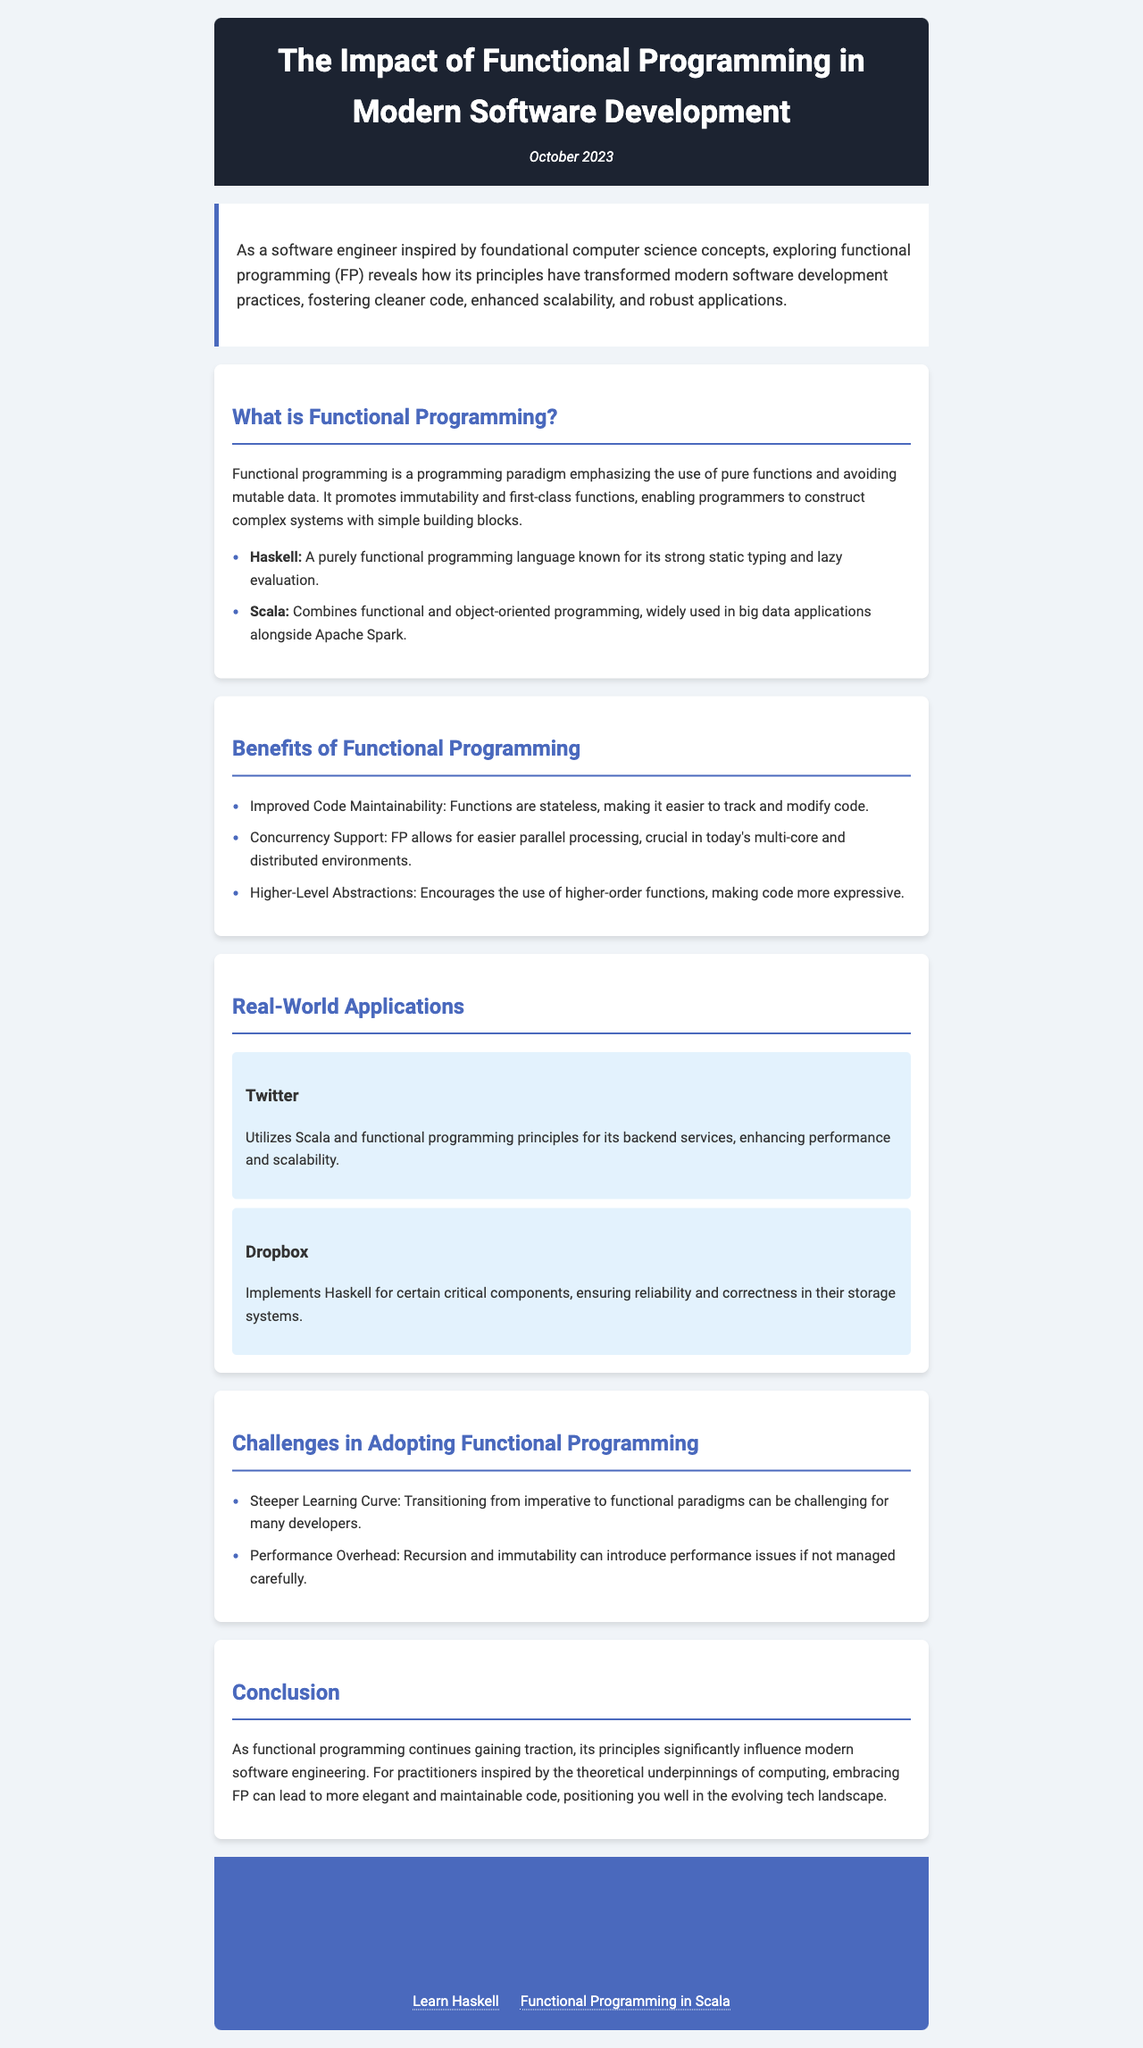What is the date of the newsletter? The date of the newsletter is mentioned in the header section.
Answer: October 2023 What programming paradigm does functional programming emphasize? The emphasis of functional programming is described in the introduction section.
Answer: Pure functions Which programming language is known for its strong static typing? The language mentioned for its strong static typing is listed in the section about functional programming.
Answer: Haskell What is one benefit of functional programming mentioned? Benefits of functional programming are listed in the corresponding section.
Answer: Improved Code Maintainability Which company uses Scala for its backend services? The company utilizing Scala is provided in the real-world applications section.
Answer: Twitter What major challenge is associated with adopting functional programming? Challenges in adopting functional programming are outlined in the specific section on this topic.
Answer: Steeper Learning Curve What is one of the real-world applications of Haskell? The example of a company using Haskell is found in the real-world applications section.
Answer: Dropbox How does functional programming benefit concurrency? The specific advantage of functional programming for concurrency is detailed in the benefits section.
Answer: Easier parallel processing 